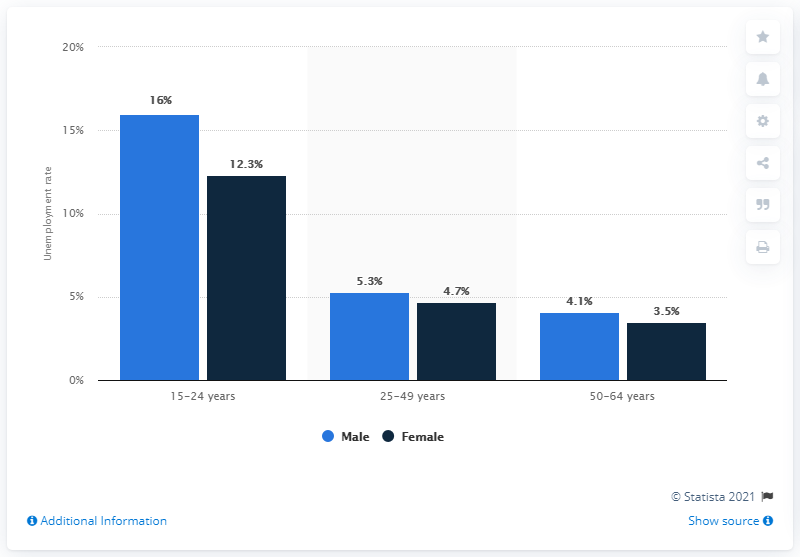Specify some key components in this picture. The difference in mean IQ scores between male and female individuals aged 50-64 years is 0.6 standard deviation units. 